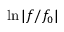Convert formula to latex. <formula><loc_0><loc_0><loc_500><loc_500>\ln | f / f _ { 0 } |</formula> 